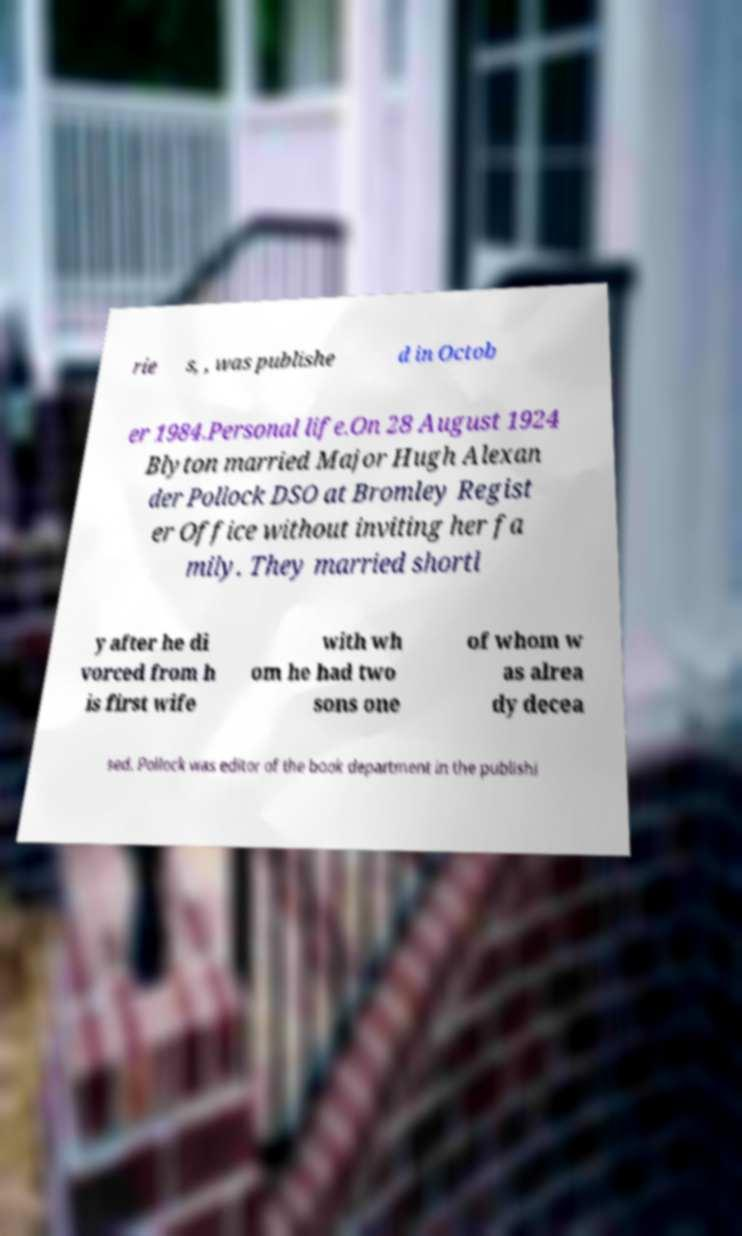I need the written content from this picture converted into text. Can you do that? rie s, , was publishe d in Octob er 1984.Personal life.On 28 August 1924 Blyton married Major Hugh Alexan der Pollock DSO at Bromley Regist er Office without inviting her fa mily. They married shortl y after he di vorced from h is first wife with wh om he had two sons one of whom w as alrea dy decea sed. Pollock was editor of the book department in the publishi 